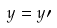<formula> <loc_0><loc_0><loc_500><loc_500>y = y \prime</formula> 